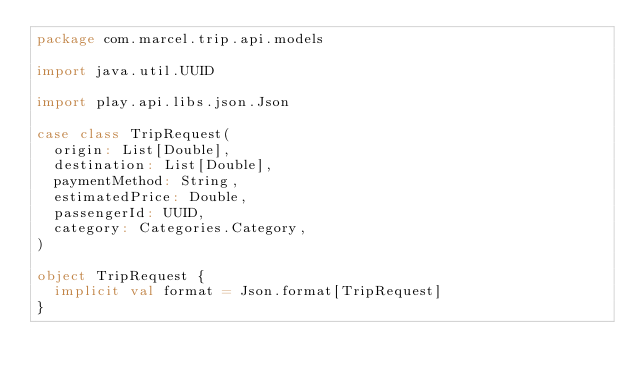<code> <loc_0><loc_0><loc_500><loc_500><_Scala_>package com.marcel.trip.api.models

import java.util.UUID

import play.api.libs.json.Json

case class TripRequest(
  origin: List[Double],
  destination: List[Double],
  paymentMethod: String,
  estimatedPrice: Double,
  passengerId: UUID,
  category: Categories.Category,
)

object TripRequest {
  implicit val format = Json.format[TripRequest]
}
</code> 